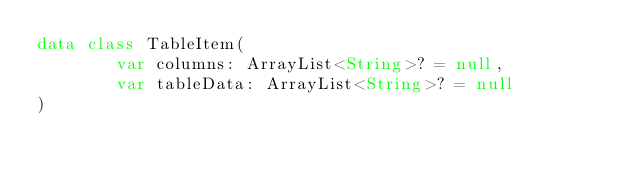Convert code to text. <code><loc_0><loc_0><loc_500><loc_500><_Kotlin_>data class TableItem(
        var columns: ArrayList<String>? = null,
        var tableData: ArrayList<String>? = null
)
</code> 